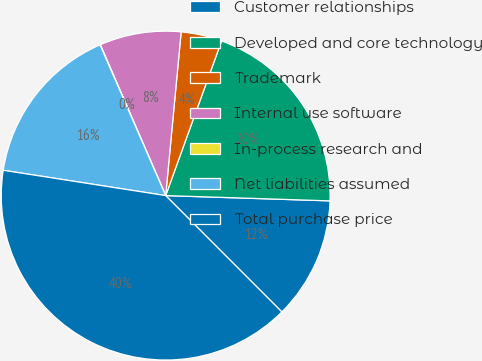<chart> <loc_0><loc_0><loc_500><loc_500><pie_chart><fcel>Customer relationships<fcel>Developed and core technology<fcel>Trademark<fcel>Internal use software<fcel>In-process research and<fcel>Net liabilities assumed<fcel>Total purchase price<nl><fcel>12.0%<fcel>19.99%<fcel>4.02%<fcel>8.01%<fcel>0.03%<fcel>16.0%<fcel>39.95%<nl></chart> 